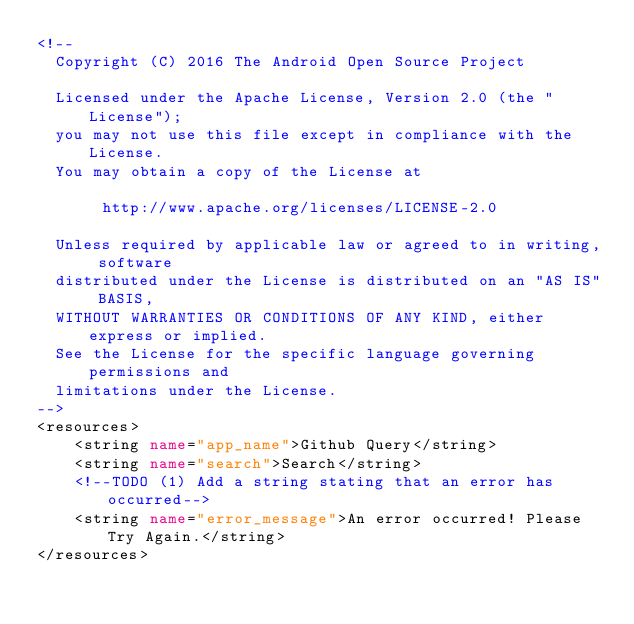<code> <loc_0><loc_0><loc_500><loc_500><_XML_><!--
  Copyright (C) 2016 The Android Open Source Project

  Licensed under the Apache License, Version 2.0 (the "License");
  you may not use this file except in compliance with the License.
  You may obtain a copy of the License at

       http://www.apache.org/licenses/LICENSE-2.0

  Unless required by applicable law or agreed to in writing, software
  distributed under the License is distributed on an "AS IS" BASIS,
  WITHOUT WARRANTIES OR CONDITIONS OF ANY KIND, either express or implied.
  See the License for the specific language governing permissions and
  limitations under the License.
-->
<resources>
    <string name="app_name">Github Query</string>
    <string name="search">Search</string>
    <!--TODO (1) Add a string stating that an error has occurred-->
    <string name="error_message">An error occurred! Please Try Again.</string>
</resources></code> 